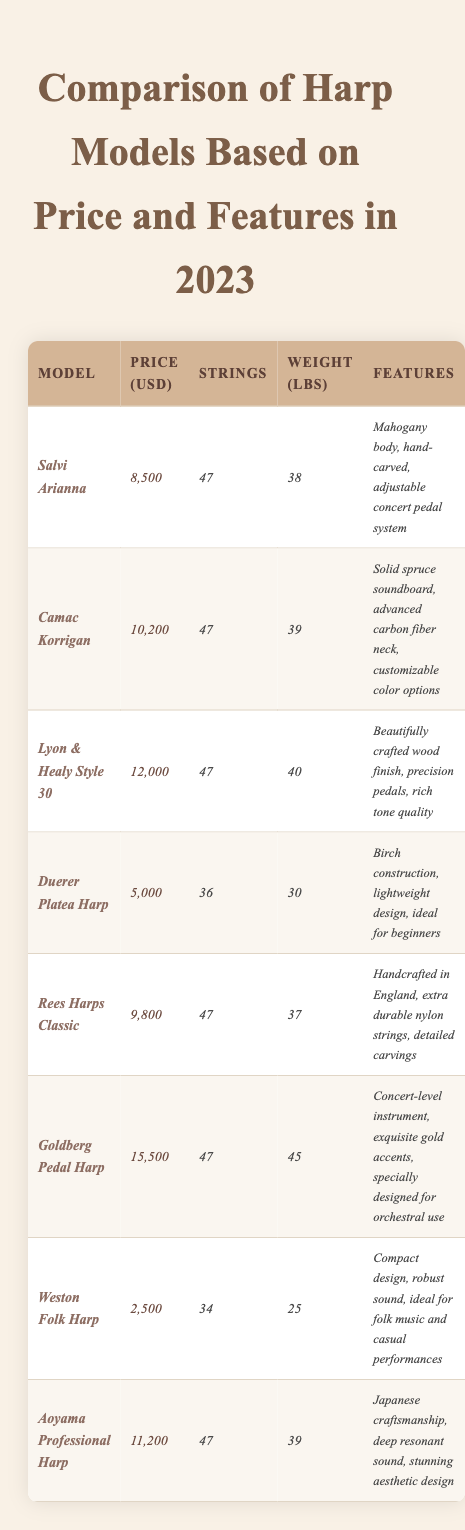What is the price of the Goldberg Pedal Harp? The table directly lists the price for each harp model. By finding *Goldberg Pedal Harp* in the Model column, we can see its price listed as *15,500* USD.
Answer: 15,500 Which harp has the most strings? Counting the number of strings for each harp model in the Strings column, we find that the *Salvi Arianna*, *Camac Korrigan*, *Lyon & Healy Style 30*, *Rees Harps Classic*, *Goldberg Pedal Harp*, and *Aoyama Professional Harp* all have *47* strings, which is the maximum.
Answer: Salvi Arianna, Camac Korrigan, Lyon & Healy Style 30, Rees Harps Classic, Goldberg Pedal Harp, Aoyama Professional Harp What is the weight difference between the heaviest and lightest harp? The heaviest harp listed is the *Goldberg Pedal Harp* at *45 lbs*, and the lightest is the *Weston Folk Harp* at *25 lbs*. Calculating the difference gives us 45 - 25 = 20 lbs.
Answer: 20 lbs Is the *Duerer Platea Harp* more affordable than the *Weston Folk Harp*? In the Price column, the *Duerer Platea Harp* is listed at *5,000* USD, while the *Weston Folk Harp* costs *2,500* USD. Since *5,000* is greater than *2,500*, it is not more affordable.
Answer: No What is the average price of all the harps listed in the table? First, we add all the harp prices: 8500 + 10200 + 12000 + 5000 + 9800 + 15500 + 2500 + 11200 =  68500. There are 8 harps, so we divide the total by 8. The average price is 68500 / 8 = 8562.5.
Answer: 8562.5 Which harp model has features that mention a soundboard? In the Features column, the *Camac Korrigan* is the only model that specifies a *solid spruce soundboard*. Checking each feature description confirms this.
Answer: Camac Korrigan Which harp is the least expensive and what are its features? The least expensive harp is the *Weston Folk Harp*, priced at *2,500* USD. Its features are described as a *compact design, robust sound, ideal for folk music and casual performances*.
Answer: Weston Folk Harp; compact design, robust sound, ideal for folk music and casual performances What is the total number of strings across all models? Adding the number of strings from each harp: 47 + 47 + 47 + 36 + 47 + 47 + 34 + 47 =  354. The total number of strings is therefore *354*.
Answer: 354 Do any harps have extra durable nylon strings? The *Rees Harps Classic* is noted for its extra durable nylon strings in the Features column. Checking this confirms that it is the only model mentioned for this feature.
Answer: Yes, Rees Harps Classic 